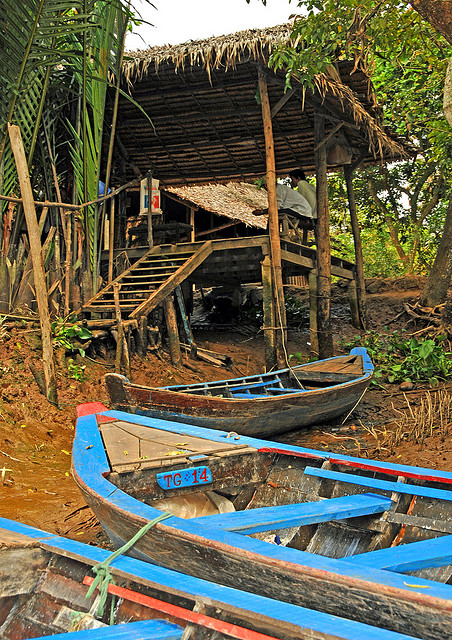Extract all visible text content from this image. TG 14 